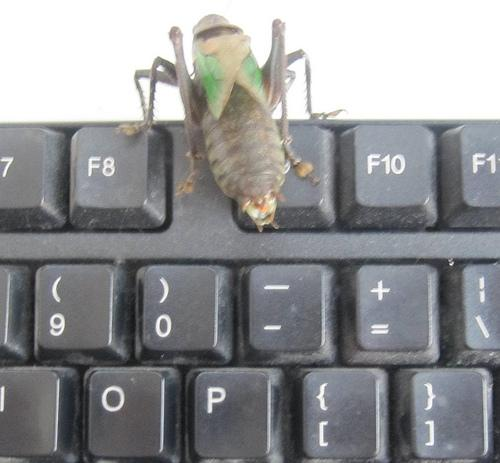Find two adjectives describing the color and appearance of the grasshopper. Green and brown Estimate the image quality based on the visibility of the letter "I" keyboard key. The image quality seems to be lower as the letter "I" keyboard key is barely visible in the photo. What sentiment does the presence of the bug on the keyboard evoke? The presence of the bug on the keyboard evokes a feeling of discomfort and disgust due to its creepy appearance. List the types of keys mentioned in the image and any accompanying attributes. F10, O, P, open bracket, closed bracket, plus and equal sign, underscore, 9, 0, F8, I, P - all on a dirty black plastic keyboard. How would you describe the overall condition of the keyboard? The keyboard appears to be dirty and dusty with dust in between the keys. Based on the information provided, what action might someone need to take with respect to the keyboard? Someone might need to clean the dirty keyboard and remove the grasshopper from it. What kind of insect is on the keyboard, and which key is it standing between? It's a grasshopper standing between the F8 and F9 keys on the computer keyboard. Identify the primary object on the keyboard and provide a brief description of its appearance. A creepy bug with green wings and brown long legs is crawling on top of a dusty black computer keyboard near the F9 key. Count the total number of brown long legs mentioned in the image description. There are two brown long legs of the bug mentioned in the image description. Explain the interaction between the insect and the keyboard. The insect, a grasshopper with green wings, is crawling on the keyboard, seemingly exploring the surface and keys. 